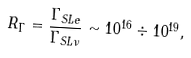<formula> <loc_0><loc_0><loc_500><loc_500>R _ { \Gamma } = \frac { \Gamma _ { S L e } } { \Gamma _ { S L \nu } } \sim 1 0 ^ { 1 6 } \div 1 0 ^ { 1 9 } ,</formula> 